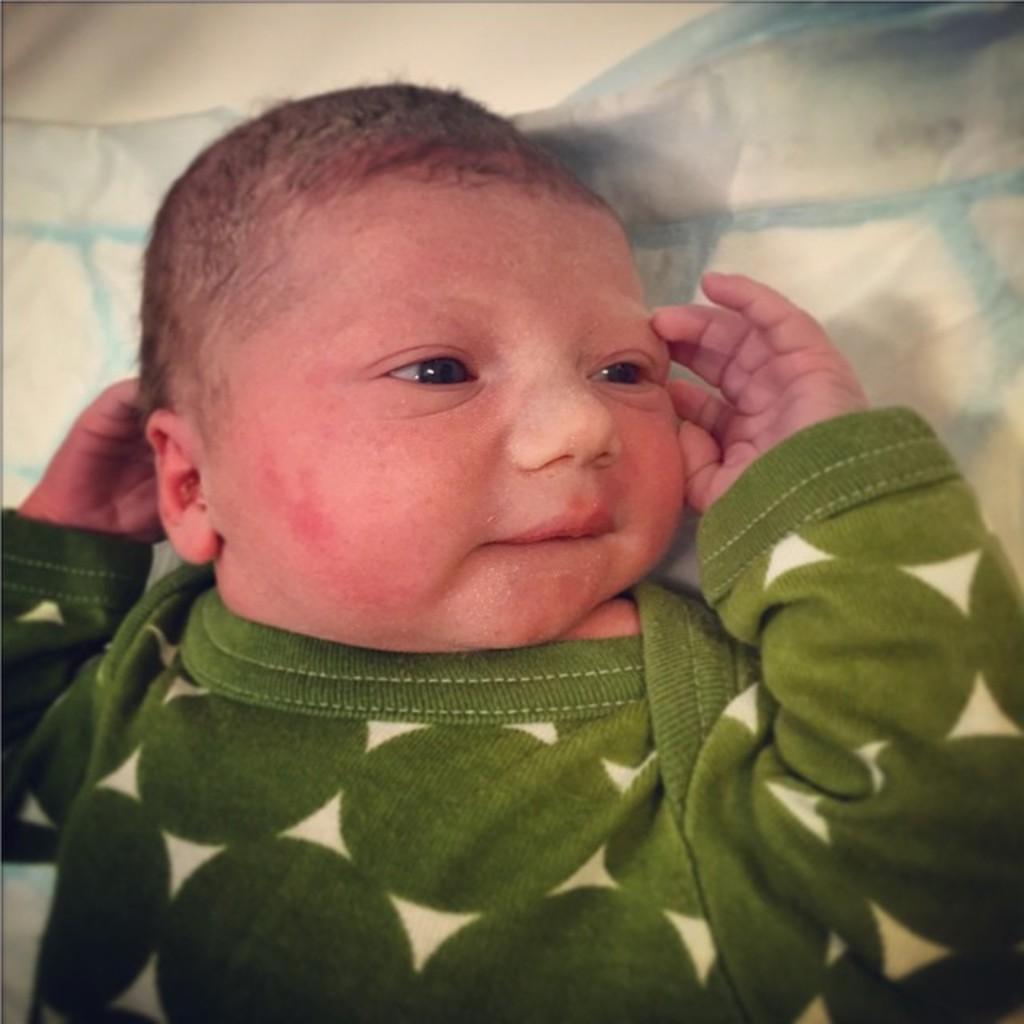Could you give a brief overview of what you see in this image? in this picture there is a small baby in the center of the image. 